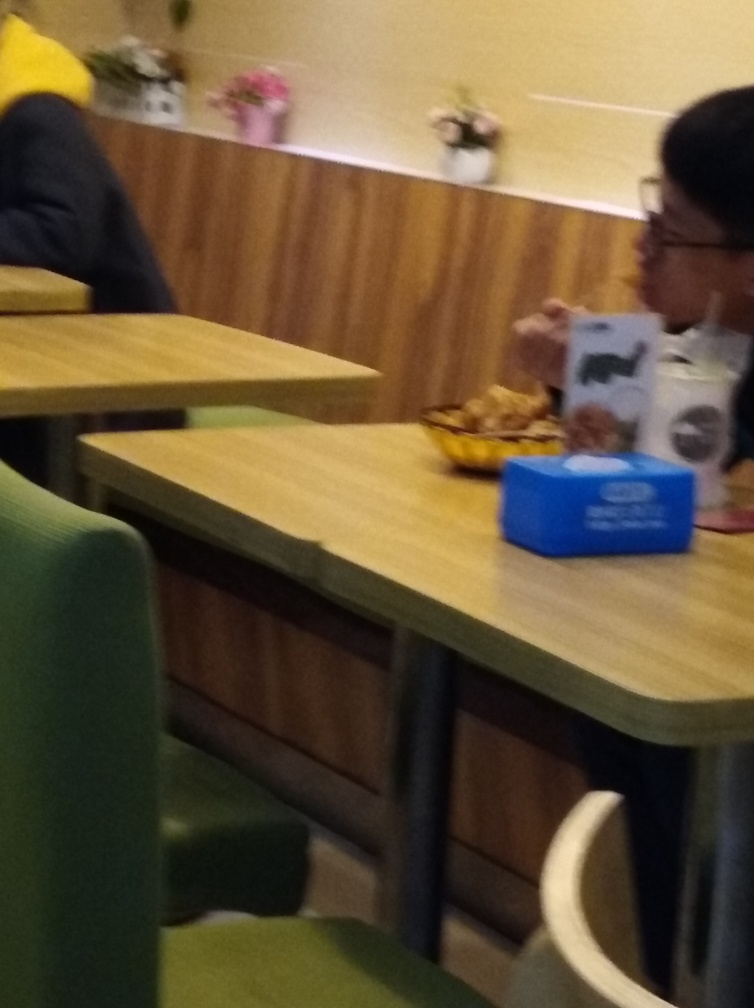Can you describe the setting and the subjects' actions in the image despite the blurriness? Despite the photo's lack of clarity, it appears to be set in a casual dining environment, possibly a cafe or fast-food restaurant, judging by the style of the furniture and the food visible on the table. There's at least one person visible, seemingly engaged in eating or possibly reading something, underscored by the casual posture and positioning at the table with food items in front. 